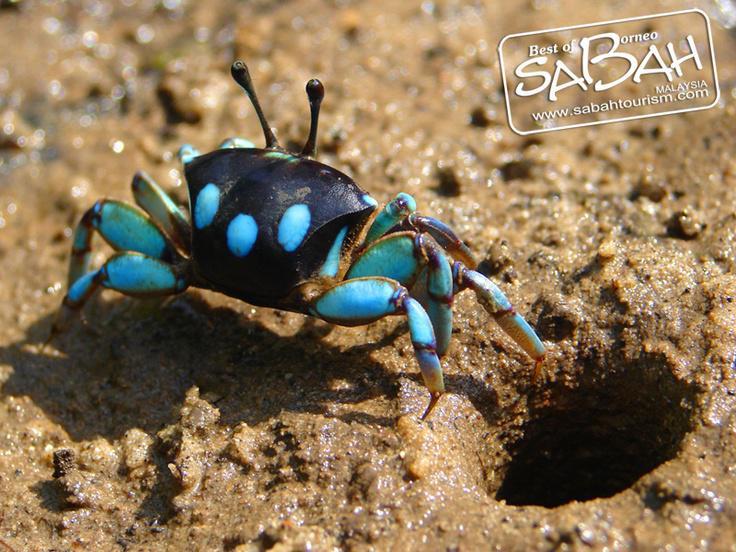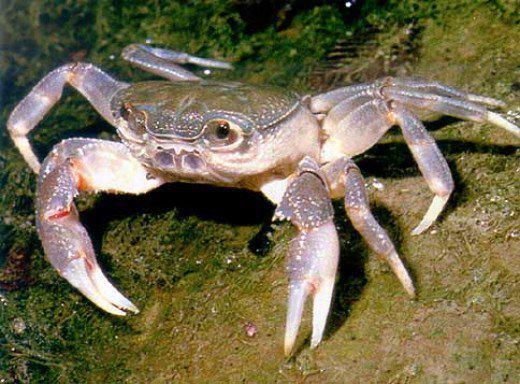The first image is the image on the left, the second image is the image on the right. Analyze the images presented: Is the assertion "Exactly one crab's left claw is higher than its right." valid? Answer yes or no. No. 